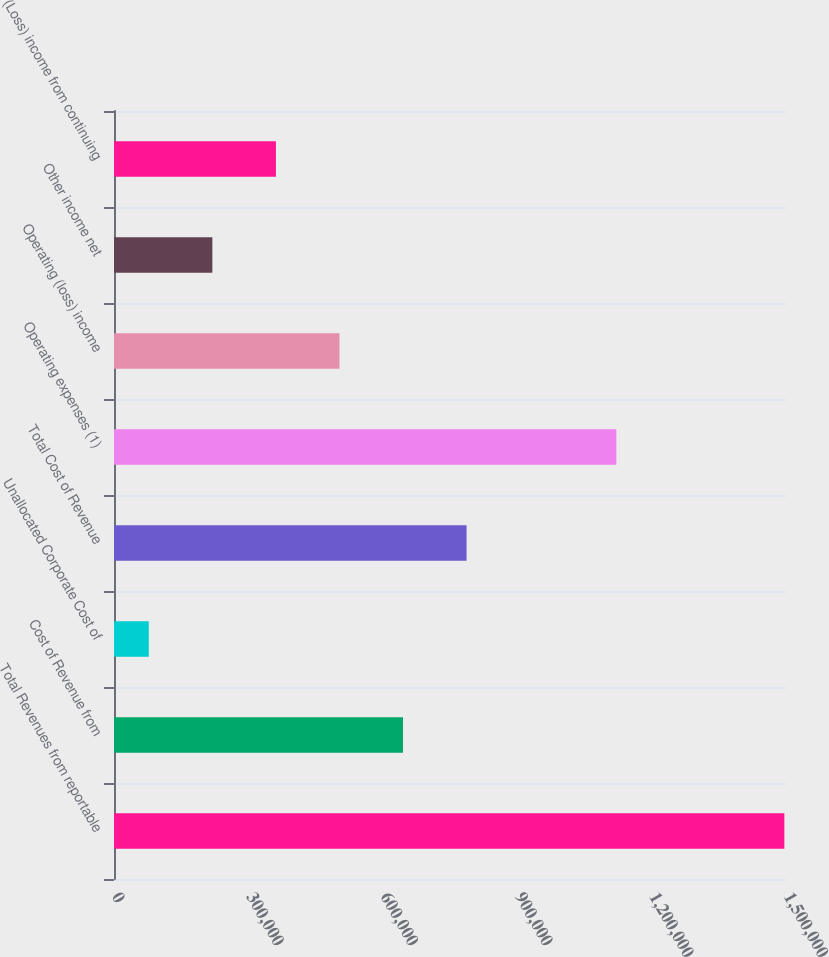<chart> <loc_0><loc_0><loc_500><loc_500><bar_chart><fcel>Total Revenues from reportable<fcel>Cost of Revenue from<fcel>Unallocated Corporate Cost of<fcel>Total Cost of Revenue<fcel>Operating expenses (1)<fcel>Operating (loss) income<fcel>Other income net<fcel>(Loss) income from continuing<nl><fcel>1.49629e+06<fcel>645113<fcel>77662<fcel>786976<fcel>1.12127e+06<fcel>503250<fcel>219525<fcel>361387<nl></chart> 